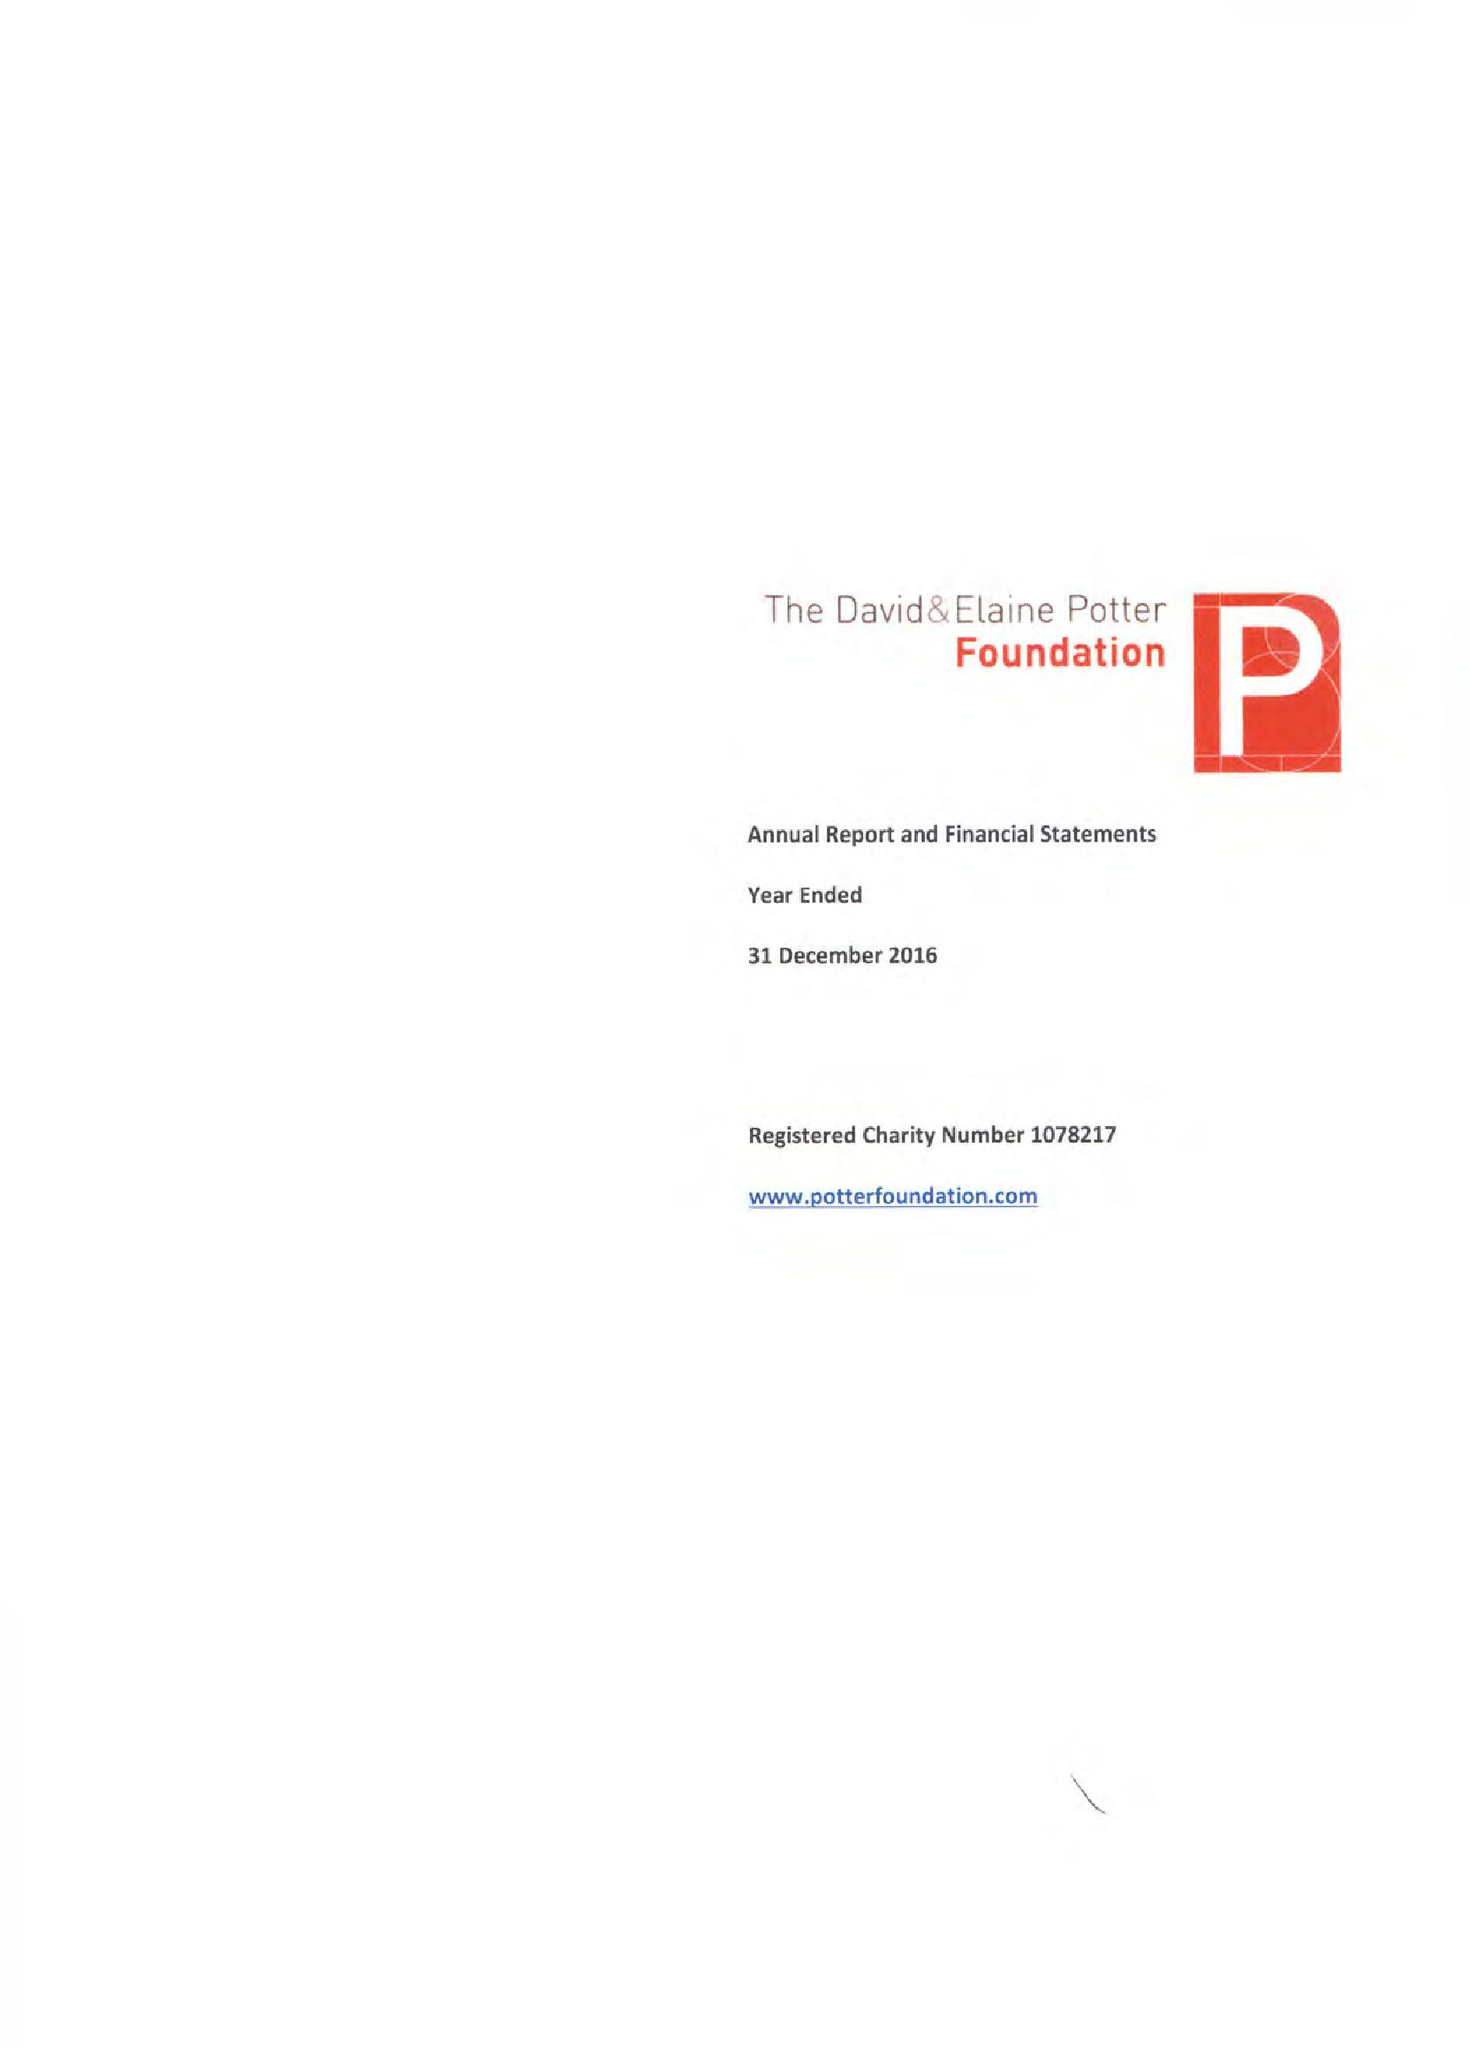What is the value for the address__post_town?
Answer the question using a single word or phrase. LONDON 